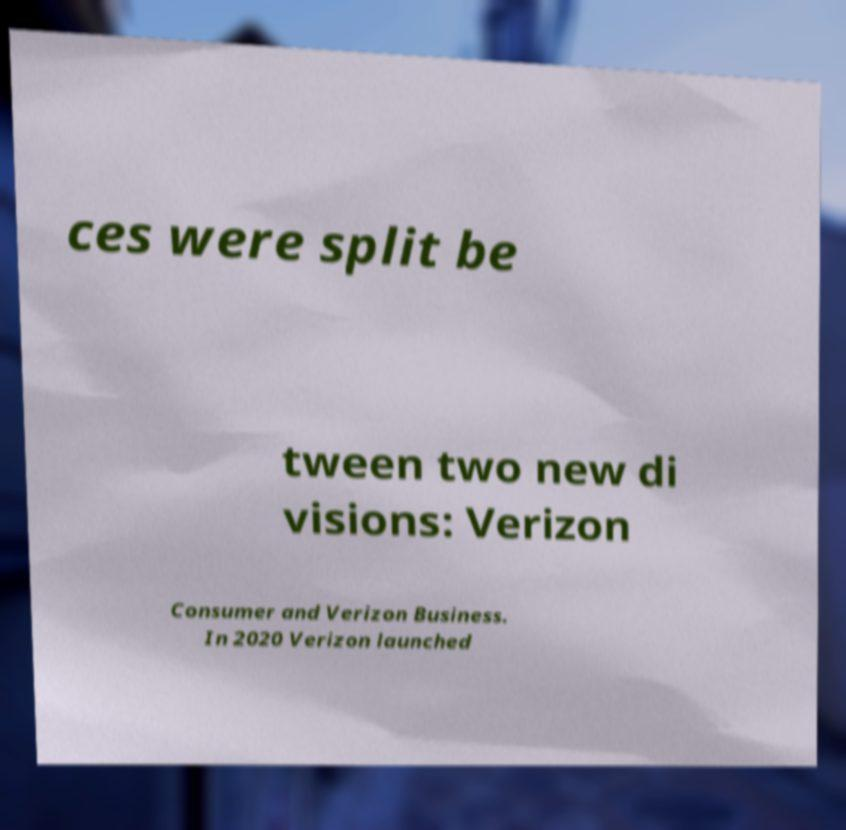There's text embedded in this image that I need extracted. Can you transcribe it verbatim? ces were split be tween two new di visions: Verizon Consumer and Verizon Business. In 2020 Verizon launched 